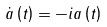<formula> <loc_0><loc_0><loc_500><loc_500>\dot { a } \left ( t \right ) = - i a \left ( t \right )</formula> 